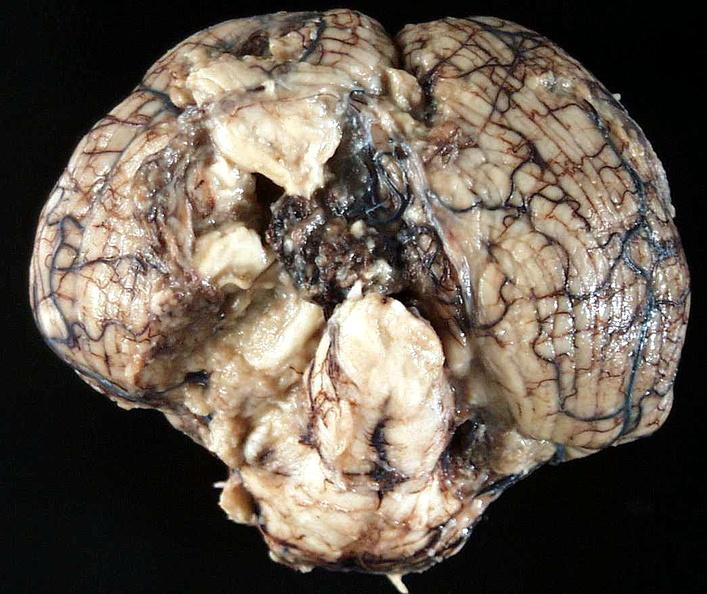does this image show brain, cryptococcal meningitis?
Answer the question using a single word or phrase. Yes 